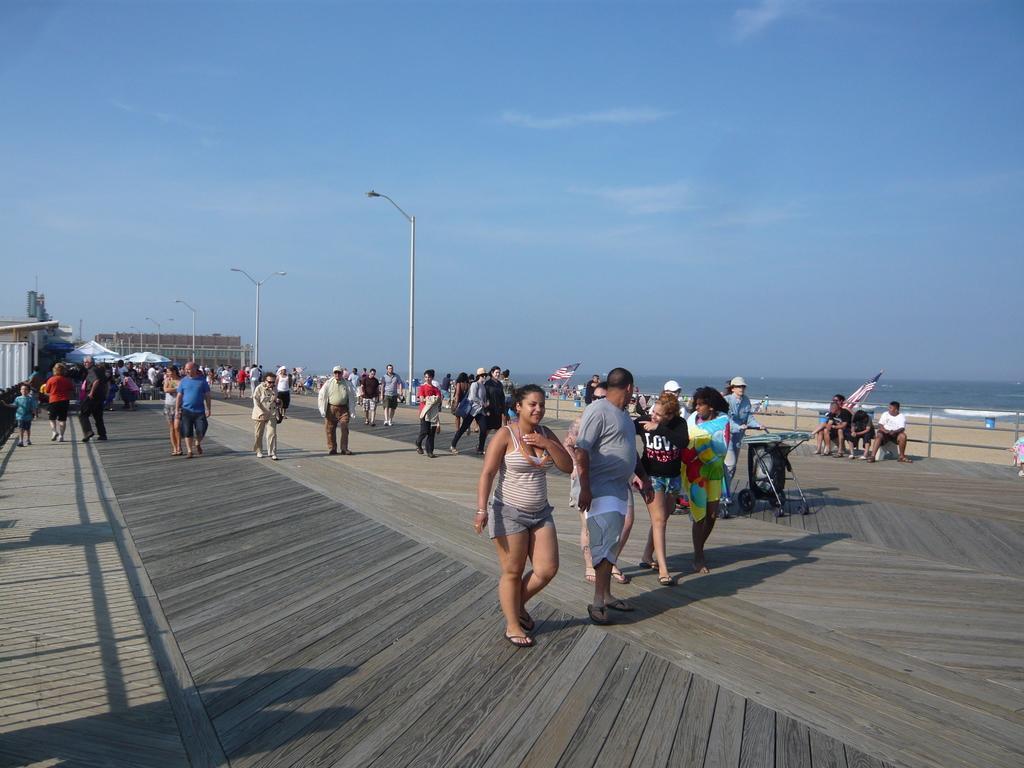Can you describe this image briefly? This image is taken outdoors. At the top of the image there is a sky with clouds. At the bottom of the image there is a road. On the right side of the image there is a sea. In the middle of the image there is a building and there are a few poles. In the middle of the image many people are walking on the road and three men are sitting on the bench. 